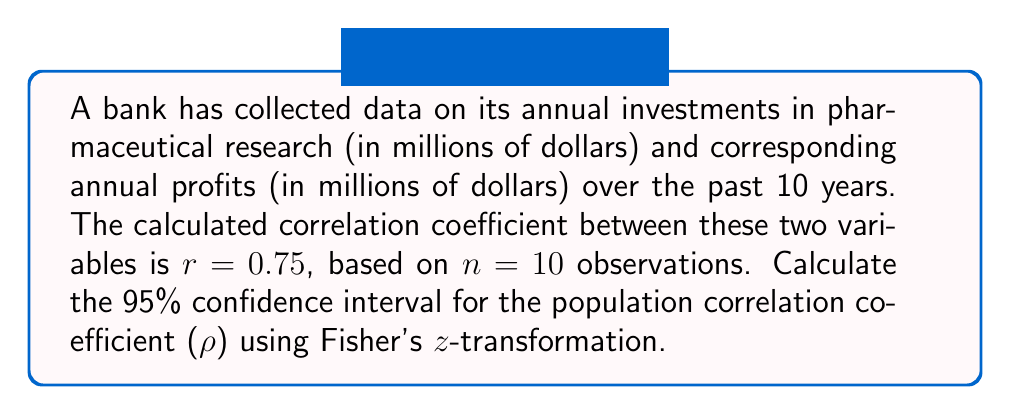Teach me how to tackle this problem. To compute the confidence interval for the correlation coefficient, we'll use Fisher's z-transformation. Here are the steps:

1) Convert r to z using Fisher's z-transformation:
   $$z = \frac{1}{2}\ln\left(\frac{1+r}{1-r}\right)$$
   $$z = \frac{1}{2}\ln\left(\frac{1+0.75}{1-0.75}\right) = 0.9730$$

2) Calculate the standard error of z:
   $$SE_z = \frac{1}{\sqrt{n-3}}$$
   $$SE_z = \frac{1}{\sqrt{10-3}} = 0.3780$$

3) For a 95% confidence interval, use z-score of 1.96. Calculate the margin of error:
   $$\text{Margin of Error} = 1.96 \times SE_z = 1.96 \times 0.3780 = 0.7408$$

4) Calculate the confidence interval for z:
   $$\text{CI}_z = (z - \text{Margin of Error}, z + \text{Margin of Error})$$
   $$\text{CI}_z = (0.9730 - 0.7408, 0.9730 + 0.7408) = (0.2322, 1.7138)$$

5) Convert the z-interval back to r-interval using the inverse of Fisher's z-transformation:
   $$r = \frac{e^{2z}-1}{e^{2z}+1}$$

   Lower bound: $$r_L = \frac{e^{2(0.2322)}-1}{e^{2(0.2322)}+1} = 0.2277$$
   Upper bound: $$r_U = \frac{e^{2(1.7138)}-1}{e^{2(1.7138)}+1} = 0.9379$$

Therefore, the 95% confidence interval for ρ is (0.2277, 0.9379).
Answer: (0.2277, 0.9379) 